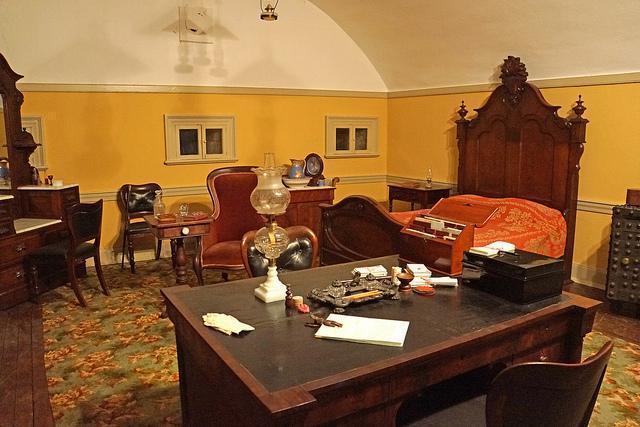What kind of fuel does the lamp use?
From the following set of four choices, select the accurate answer to respond to the question.
Options: Manure, fossil, wood, solar. Fossil. 